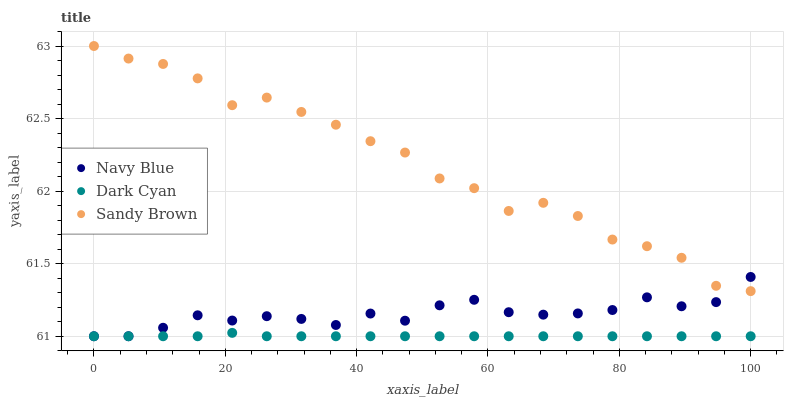Does Dark Cyan have the minimum area under the curve?
Answer yes or no. Yes. Does Sandy Brown have the maximum area under the curve?
Answer yes or no. Yes. Does Navy Blue have the minimum area under the curve?
Answer yes or no. No. Does Navy Blue have the maximum area under the curve?
Answer yes or no. No. Is Dark Cyan the smoothest?
Answer yes or no. Yes. Is Sandy Brown the roughest?
Answer yes or no. Yes. Is Navy Blue the smoothest?
Answer yes or no. No. Is Navy Blue the roughest?
Answer yes or no. No. Does Dark Cyan have the lowest value?
Answer yes or no. Yes. Does Sandy Brown have the lowest value?
Answer yes or no. No. Does Sandy Brown have the highest value?
Answer yes or no. Yes. Does Navy Blue have the highest value?
Answer yes or no. No. Is Dark Cyan less than Sandy Brown?
Answer yes or no. Yes. Is Sandy Brown greater than Dark Cyan?
Answer yes or no. Yes. Does Navy Blue intersect Sandy Brown?
Answer yes or no. Yes. Is Navy Blue less than Sandy Brown?
Answer yes or no. No. Is Navy Blue greater than Sandy Brown?
Answer yes or no. No. Does Dark Cyan intersect Sandy Brown?
Answer yes or no. No. 